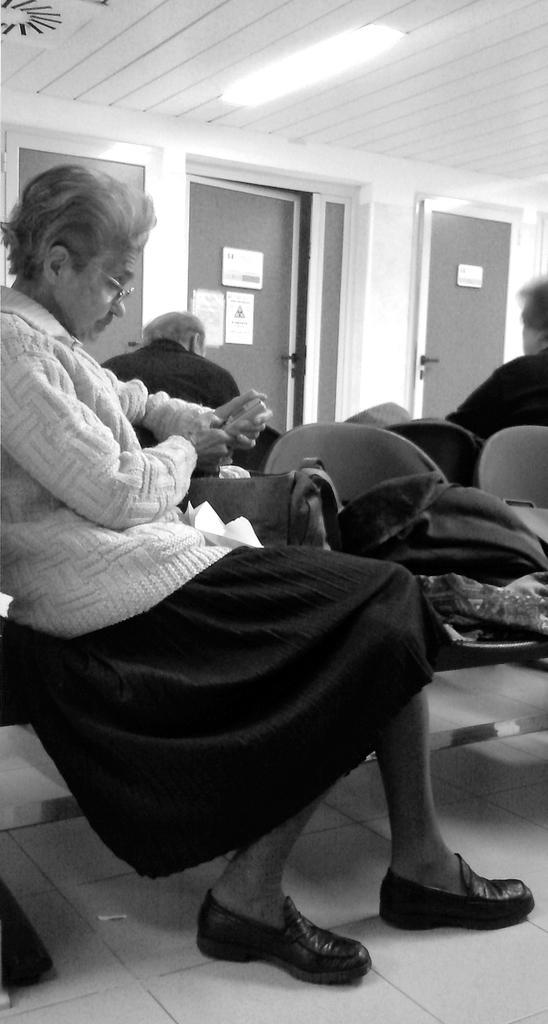Who is the main subject in the image? There is a woman in the image. What is the woman wearing? The woman is wearing a white jacket. What is the woman doing in the image? The woman is sitting in a chair. Can you describe the background of the image? There are two persons and other objects in the background of the image. What type of rod is the woman using to complete her journey in the image? There is no rod or journey present in the image; it features a woman sitting in a chair wearing a white jacket. 